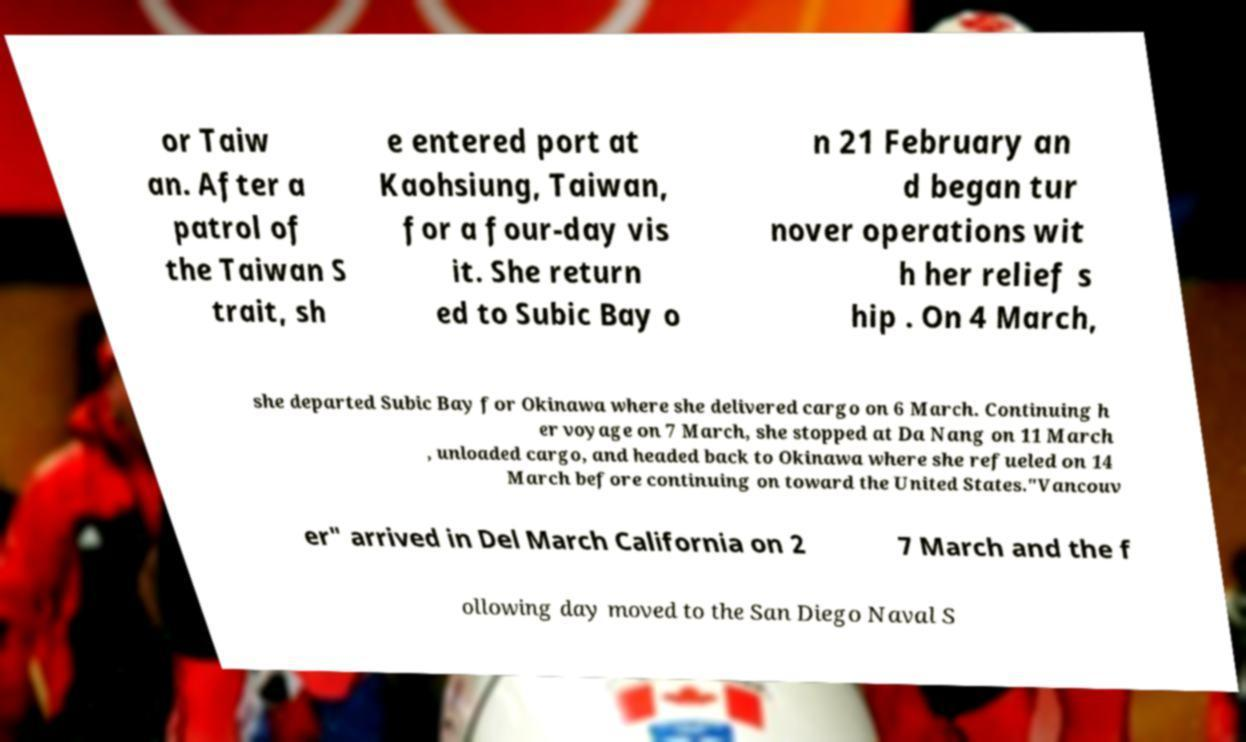Could you assist in decoding the text presented in this image and type it out clearly? or Taiw an. After a patrol of the Taiwan S trait, sh e entered port at Kaohsiung, Taiwan, for a four-day vis it. She return ed to Subic Bay o n 21 February an d began tur nover operations wit h her relief s hip . On 4 March, she departed Subic Bay for Okinawa where she delivered cargo on 6 March. Continuing h er voyage on 7 March, she stopped at Da Nang on 11 March , unloaded cargo, and headed back to Okinawa where she refueled on 14 March before continuing on toward the United States."Vancouv er" arrived in Del March California on 2 7 March and the f ollowing day moved to the San Diego Naval S 